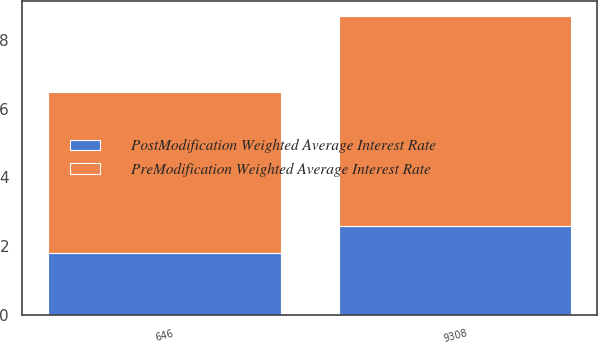Convert chart. <chart><loc_0><loc_0><loc_500><loc_500><stacked_bar_chart><ecel><fcel>9308<fcel>646<nl><fcel>PreModification Weighted Average Interest Rate<fcel>6.1<fcel>4.7<nl><fcel>PostModification Weighted Average Interest Rate<fcel>2.6<fcel>1.8<nl></chart> 